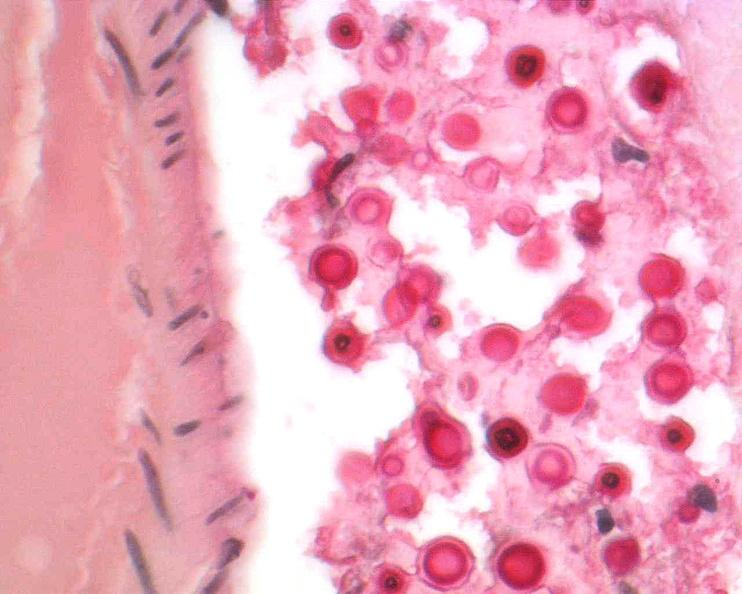what is present?
Answer the question using a single word or phrase. Nervous 